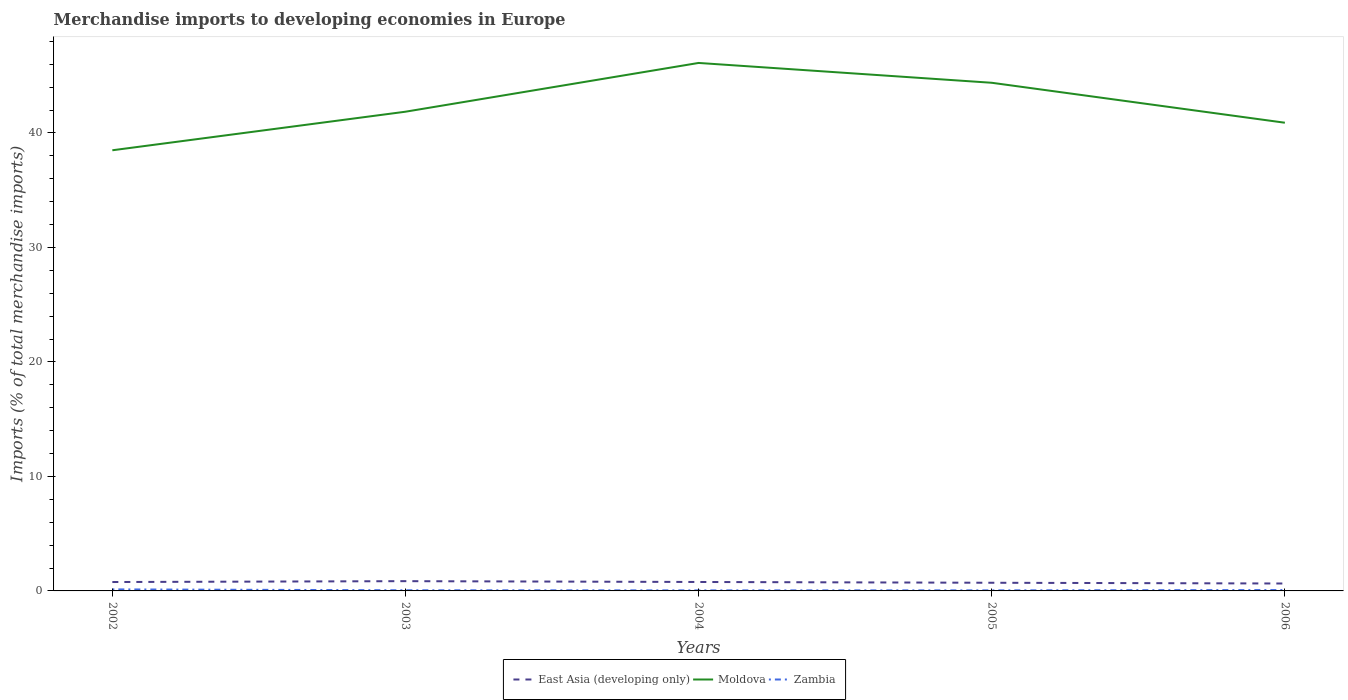Is the number of lines equal to the number of legend labels?
Provide a succinct answer. Yes. Across all years, what is the maximum percentage total merchandise imports in Zambia?
Give a very brief answer. 0.05. What is the total percentage total merchandise imports in East Asia (developing only) in the graph?
Make the answer very short. 0.07. What is the difference between the highest and the second highest percentage total merchandise imports in Moldova?
Offer a terse response. 7.63. Does the graph contain grids?
Ensure brevity in your answer.  No. Where does the legend appear in the graph?
Provide a short and direct response. Bottom center. How many legend labels are there?
Offer a very short reply. 3. What is the title of the graph?
Your answer should be very brief. Merchandise imports to developing economies in Europe. What is the label or title of the Y-axis?
Keep it short and to the point. Imports (% of total merchandise imports). What is the Imports (% of total merchandise imports) in East Asia (developing only) in 2002?
Your answer should be very brief. 0.78. What is the Imports (% of total merchandise imports) in Moldova in 2002?
Keep it short and to the point. 38.49. What is the Imports (% of total merchandise imports) in Zambia in 2002?
Provide a short and direct response. 0.13. What is the Imports (% of total merchandise imports) in East Asia (developing only) in 2003?
Offer a very short reply. 0.85. What is the Imports (% of total merchandise imports) in Moldova in 2003?
Make the answer very short. 41.86. What is the Imports (% of total merchandise imports) in Zambia in 2003?
Make the answer very short. 0.06. What is the Imports (% of total merchandise imports) in East Asia (developing only) in 2004?
Make the answer very short. 0.78. What is the Imports (% of total merchandise imports) of Moldova in 2004?
Your answer should be compact. 46.12. What is the Imports (% of total merchandise imports) of Zambia in 2004?
Make the answer very short. 0.05. What is the Imports (% of total merchandise imports) of East Asia (developing only) in 2005?
Give a very brief answer. 0.71. What is the Imports (% of total merchandise imports) of Moldova in 2005?
Ensure brevity in your answer.  44.39. What is the Imports (% of total merchandise imports) of Zambia in 2005?
Your answer should be very brief. 0.05. What is the Imports (% of total merchandise imports) of East Asia (developing only) in 2006?
Your response must be concise. 0.65. What is the Imports (% of total merchandise imports) of Moldova in 2006?
Provide a short and direct response. 40.9. What is the Imports (% of total merchandise imports) of Zambia in 2006?
Give a very brief answer. 0.08. Across all years, what is the maximum Imports (% of total merchandise imports) in East Asia (developing only)?
Offer a terse response. 0.85. Across all years, what is the maximum Imports (% of total merchandise imports) in Moldova?
Provide a succinct answer. 46.12. Across all years, what is the maximum Imports (% of total merchandise imports) in Zambia?
Your response must be concise. 0.13. Across all years, what is the minimum Imports (% of total merchandise imports) in East Asia (developing only)?
Ensure brevity in your answer.  0.65. Across all years, what is the minimum Imports (% of total merchandise imports) in Moldova?
Ensure brevity in your answer.  38.49. Across all years, what is the minimum Imports (% of total merchandise imports) of Zambia?
Make the answer very short. 0.05. What is the total Imports (% of total merchandise imports) of East Asia (developing only) in the graph?
Offer a very short reply. 3.77. What is the total Imports (% of total merchandise imports) in Moldova in the graph?
Your answer should be compact. 211.75. What is the total Imports (% of total merchandise imports) of Zambia in the graph?
Your response must be concise. 0.36. What is the difference between the Imports (% of total merchandise imports) in East Asia (developing only) in 2002 and that in 2003?
Provide a succinct answer. -0.08. What is the difference between the Imports (% of total merchandise imports) of Moldova in 2002 and that in 2003?
Provide a short and direct response. -3.37. What is the difference between the Imports (% of total merchandise imports) in Zambia in 2002 and that in 2003?
Provide a succinct answer. 0.08. What is the difference between the Imports (% of total merchandise imports) of East Asia (developing only) in 2002 and that in 2004?
Your response must be concise. -0. What is the difference between the Imports (% of total merchandise imports) in Moldova in 2002 and that in 2004?
Offer a terse response. -7.63. What is the difference between the Imports (% of total merchandise imports) in Zambia in 2002 and that in 2004?
Provide a succinct answer. 0.09. What is the difference between the Imports (% of total merchandise imports) in East Asia (developing only) in 2002 and that in 2005?
Keep it short and to the point. 0.06. What is the difference between the Imports (% of total merchandise imports) in Moldova in 2002 and that in 2005?
Keep it short and to the point. -5.9. What is the difference between the Imports (% of total merchandise imports) of Zambia in 2002 and that in 2005?
Keep it short and to the point. 0.09. What is the difference between the Imports (% of total merchandise imports) in East Asia (developing only) in 2002 and that in 2006?
Provide a short and direct response. 0.13. What is the difference between the Imports (% of total merchandise imports) of Moldova in 2002 and that in 2006?
Give a very brief answer. -2.41. What is the difference between the Imports (% of total merchandise imports) in Zambia in 2002 and that in 2006?
Offer a terse response. 0.06. What is the difference between the Imports (% of total merchandise imports) in East Asia (developing only) in 2003 and that in 2004?
Make the answer very short. 0.07. What is the difference between the Imports (% of total merchandise imports) in Moldova in 2003 and that in 2004?
Offer a very short reply. -4.26. What is the difference between the Imports (% of total merchandise imports) in Zambia in 2003 and that in 2004?
Make the answer very short. 0.01. What is the difference between the Imports (% of total merchandise imports) in East Asia (developing only) in 2003 and that in 2005?
Offer a very short reply. 0.14. What is the difference between the Imports (% of total merchandise imports) in Moldova in 2003 and that in 2005?
Offer a terse response. -2.53. What is the difference between the Imports (% of total merchandise imports) in Zambia in 2003 and that in 2005?
Provide a short and direct response. 0.01. What is the difference between the Imports (% of total merchandise imports) of East Asia (developing only) in 2003 and that in 2006?
Ensure brevity in your answer.  0.2. What is the difference between the Imports (% of total merchandise imports) in Moldova in 2003 and that in 2006?
Provide a short and direct response. 0.96. What is the difference between the Imports (% of total merchandise imports) of Zambia in 2003 and that in 2006?
Provide a succinct answer. -0.02. What is the difference between the Imports (% of total merchandise imports) of East Asia (developing only) in 2004 and that in 2005?
Your response must be concise. 0.07. What is the difference between the Imports (% of total merchandise imports) of Moldova in 2004 and that in 2005?
Offer a very short reply. 1.73. What is the difference between the Imports (% of total merchandise imports) of Zambia in 2004 and that in 2005?
Offer a very short reply. -0. What is the difference between the Imports (% of total merchandise imports) in East Asia (developing only) in 2004 and that in 2006?
Offer a terse response. 0.13. What is the difference between the Imports (% of total merchandise imports) in Moldova in 2004 and that in 2006?
Offer a terse response. 5.22. What is the difference between the Imports (% of total merchandise imports) of Zambia in 2004 and that in 2006?
Give a very brief answer. -0.03. What is the difference between the Imports (% of total merchandise imports) in East Asia (developing only) in 2005 and that in 2006?
Offer a terse response. 0.07. What is the difference between the Imports (% of total merchandise imports) of Moldova in 2005 and that in 2006?
Your response must be concise. 3.49. What is the difference between the Imports (% of total merchandise imports) of Zambia in 2005 and that in 2006?
Give a very brief answer. -0.03. What is the difference between the Imports (% of total merchandise imports) of East Asia (developing only) in 2002 and the Imports (% of total merchandise imports) of Moldova in 2003?
Provide a short and direct response. -41.08. What is the difference between the Imports (% of total merchandise imports) in East Asia (developing only) in 2002 and the Imports (% of total merchandise imports) in Zambia in 2003?
Your answer should be very brief. 0.72. What is the difference between the Imports (% of total merchandise imports) of Moldova in 2002 and the Imports (% of total merchandise imports) of Zambia in 2003?
Keep it short and to the point. 38.43. What is the difference between the Imports (% of total merchandise imports) of East Asia (developing only) in 2002 and the Imports (% of total merchandise imports) of Moldova in 2004?
Your answer should be compact. -45.34. What is the difference between the Imports (% of total merchandise imports) in East Asia (developing only) in 2002 and the Imports (% of total merchandise imports) in Zambia in 2004?
Offer a terse response. 0.73. What is the difference between the Imports (% of total merchandise imports) in Moldova in 2002 and the Imports (% of total merchandise imports) in Zambia in 2004?
Offer a terse response. 38.44. What is the difference between the Imports (% of total merchandise imports) of East Asia (developing only) in 2002 and the Imports (% of total merchandise imports) of Moldova in 2005?
Provide a short and direct response. -43.61. What is the difference between the Imports (% of total merchandise imports) in East Asia (developing only) in 2002 and the Imports (% of total merchandise imports) in Zambia in 2005?
Make the answer very short. 0.73. What is the difference between the Imports (% of total merchandise imports) of Moldova in 2002 and the Imports (% of total merchandise imports) of Zambia in 2005?
Offer a very short reply. 38.44. What is the difference between the Imports (% of total merchandise imports) in East Asia (developing only) in 2002 and the Imports (% of total merchandise imports) in Moldova in 2006?
Your answer should be very brief. -40.12. What is the difference between the Imports (% of total merchandise imports) in East Asia (developing only) in 2002 and the Imports (% of total merchandise imports) in Zambia in 2006?
Give a very brief answer. 0.7. What is the difference between the Imports (% of total merchandise imports) in Moldova in 2002 and the Imports (% of total merchandise imports) in Zambia in 2006?
Keep it short and to the point. 38.41. What is the difference between the Imports (% of total merchandise imports) of East Asia (developing only) in 2003 and the Imports (% of total merchandise imports) of Moldova in 2004?
Provide a short and direct response. -45.27. What is the difference between the Imports (% of total merchandise imports) of East Asia (developing only) in 2003 and the Imports (% of total merchandise imports) of Zambia in 2004?
Keep it short and to the point. 0.81. What is the difference between the Imports (% of total merchandise imports) of Moldova in 2003 and the Imports (% of total merchandise imports) of Zambia in 2004?
Make the answer very short. 41.81. What is the difference between the Imports (% of total merchandise imports) of East Asia (developing only) in 2003 and the Imports (% of total merchandise imports) of Moldova in 2005?
Your response must be concise. -43.53. What is the difference between the Imports (% of total merchandise imports) in East Asia (developing only) in 2003 and the Imports (% of total merchandise imports) in Zambia in 2005?
Provide a succinct answer. 0.8. What is the difference between the Imports (% of total merchandise imports) in Moldova in 2003 and the Imports (% of total merchandise imports) in Zambia in 2005?
Give a very brief answer. 41.81. What is the difference between the Imports (% of total merchandise imports) of East Asia (developing only) in 2003 and the Imports (% of total merchandise imports) of Moldova in 2006?
Your response must be concise. -40.04. What is the difference between the Imports (% of total merchandise imports) of East Asia (developing only) in 2003 and the Imports (% of total merchandise imports) of Zambia in 2006?
Ensure brevity in your answer.  0.78. What is the difference between the Imports (% of total merchandise imports) of Moldova in 2003 and the Imports (% of total merchandise imports) of Zambia in 2006?
Make the answer very short. 41.78. What is the difference between the Imports (% of total merchandise imports) of East Asia (developing only) in 2004 and the Imports (% of total merchandise imports) of Moldova in 2005?
Your answer should be compact. -43.6. What is the difference between the Imports (% of total merchandise imports) in East Asia (developing only) in 2004 and the Imports (% of total merchandise imports) in Zambia in 2005?
Offer a terse response. 0.73. What is the difference between the Imports (% of total merchandise imports) of Moldova in 2004 and the Imports (% of total merchandise imports) of Zambia in 2005?
Your answer should be very brief. 46.07. What is the difference between the Imports (% of total merchandise imports) in East Asia (developing only) in 2004 and the Imports (% of total merchandise imports) in Moldova in 2006?
Make the answer very short. -40.12. What is the difference between the Imports (% of total merchandise imports) of East Asia (developing only) in 2004 and the Imports (% of total merchandise imports) of Zambia in 2006?
Your answer should be very brief. 0.7. What is the difference between the Imports (% of total merchandise imports) in Moldova in 2004 and the Imports (% of total merchandise imports) in Zambia in 2006?
Make the answer very short. 46.04. What is the difference between the Imports (% of total merchandise imports) of East Asia (developing only) in 2005 and the Imports (% of total merchandise imports) of Moldova in 2006?
Give a very brief answer. -40.18. What is the difference between the Imports (% of total merchandise imports) of East Asia (developing only) in 2005 and the Imports (% of total merchandise imports) of Zambia in 2006?
Make the answer very short. 0.64. What is the difference between the Imports (% of total merchandise imports) in Moldova in 2005 and the Imports (% of total merchandise imports) in Zambia in 2006?
Provide a short and direct response. 44.31. What is the average Imports (% of total merchandise imports) in East Asia (developing only) per year?
Provide a short and direct response. 0.75. What is the average Imports (% of total merchandise imports) of Moldova per year?
Offer a terse response. 42.35. What is the average Imports (% of total merchandise imports) in Zambia per year?
Offer a very short reply. 0.07. In the year 2002, what is the difference between the Imports (% of total merchandise imports) in East Asia (developing only) and Imports (% of total merchandise imports) in Moldova?
Provide a succinct answer. -37.71. In the year 2002, what is the difference between the Imports (% of total merchandise imports) in East Asia (developing only) and Imports (% of total merchandise imports) in Zambia?
Your answer should be compact. 0.64. In the year 2002, what is the difference between the Imports (% of total merchandise imports) of Moldova and Imports (% of total merchandise imports) of Zambia?
Your answer should be very brief. 38.36. In the year 2003, what is the difference between the Imports (% of total merchandise imports) of East Asia (developing only) and Imports (% of total merchandise imports) of Moldova?
Your response must be concise. -41.01. In the year 2003, what is the difference between the Imports (% of total merchandise imports) in East Asia (developing only) and Imports (% of total merchandise imports) in Zambia?
Ensure brevity in your answer.  0.8. In the year 2003, what is the difference between the Imports (% of total merchandise imports) of Moldova and Imports (% of total merchandise imports) of Zambia?
Offer a terse response. 41.8. In the year 2004, what is the difference between the Imports (% of total merchandise imports) in East Asia (developing only) and Imports (% of total merchandise imports) in Moldova?
Give a very brief answer. -45.34. In the year 2004, what is the difference between the Imports (% of total merchandise imports) of East Asia (developing only) and Imports (% of total merchandise imports) of Zambia?
Your response must be concise. 0.73. In the year 2004, what is the difference between the Imports (% of total merchandise imports) of Moldova and Imports (% of total merchandise imports) of Zambia?
Keep it short and to the point. 46.07. In the year 2005, what is the difference between the Imports (% of total merchandise imports) of East Asia (developing only) and Imports (% of total merchandise imports) of Moldova?
Make the answer very short. -43.67. In the year 2005, what is the difference between the Imports (% of total merchandise imports) in East Asia (developing only) and Imports (% of total merchandise imports) in Zambia?
Provide a succinct answer. 0.67. In the year 2005, what is the difference between the Imports (% of total merchandise imports) in Moldova and Imports (% of total merchandise imports) in Zambia?
Your response must be concise. 44.34. In the year 2006, what is the difference between the Imports (% of total merchandise imports) in East Asia (developing only) and Imports (% of total merchandise imports) in Moldova?
Keep it short and to the point. -40.25. In the year 2006, what is the difference between the Imports (% of total merchandise imports) in East Asia (developing only) and Imports (% of total merchandise imports) in Zambia?
Ensure brevity in your answer.  0.57. In the year 2006, what is the difference between the Imports (% of total merchandise imports) in Moldova and Imports (% of total merchandise imports) in Zambia?
Your response must be concise. 40.82. What is the ratio of the Imports (% of total merchandise imports) in East Asia (developing only) in 2002 to that in 2003?
Your answer should be very brief. 0.91. What is the ratio of the Imports (% of total merchandise imports) of Moldova in 2002 to that in 2003?
Your answer should be compact. 0.92. What is the ratio of the Imports (% of total merchandise imports) of Zambia in 2002 to that in 2003?
Your answer should be very brief. 2.39. What is the ratio of the Imports (% of total merchandise imports) of Moldova in 2002 to that in 2004?
Offer a very short reply. 0.83. What is the ratio of the Imports (% of total merchandise imports) of Zambia in 2002 to that in 2004?
Offer a terse response. 2.88. What is the ratio of the Imports (% of total merchandise imports) in East Asia (developing only) in 2002 to that in 2005?
Give a very brief answer. 1.09. What is the ratio of the Imports (% of total merchandise imports) in Moldova in 2002 to that in 2005?
Your response must be concise. 0.87. What is the ratio of the Imports (% of total merchandise imports) in Zambia in 2002 to that in 2005?
Offer a very short reply. 2.8. What is the ratio of the Imports (% of total merchandise imports) in East Asia (developing only) in 2002 to that in 2006?
Your response must be concise. 1.2. What is the ratio of the Imports (% of total merchandise imports) of Moldova in 2002 to that in 2006?
Keep it short and to the point. 0.94. What is the ratio of the Imports (% of total merchandise imports) of Zambia in 2002 to that in 2006?
Offer a very short reply. 1.75. What is the ratio of the Imports (% of total merchandise imports) of East Asia (developing only) in 2003 to that in 2004?
Keep it short and to the point. 1.09. What is the ratio of the Imports (% of total merchandise imports) in Moldova in 2003 to that in 2004?
Provide a succinct answer. 0.91. What is the ratio of the Imports (% of total merchandise imports) of Zambia in 2003 to that in 2004?
Offer a very short reply. 1.2. What is the ratio of the Imports (% of total merchandise imports) of East Asia (developing only) in 2003 to that in 2005?
Give a very brief answer. 1.2. What is the ratio of the Imports (% of total merchandise imports) of Moldova in 2003 to that in 2005?
Keep it short and to the point. 0.94. What is the ratio of the Imports (% of total merchandise imports) of Zambia in 2003 to that in 2005?
Offer a terse response. 1.17. What is the ratio of the Imports (% of total merchandise imports) in East Asia (developing only) in 2003 to that in 2006?
Your response must be concise. 1.32. What is the ratio of the Imports (% of total merchandise imports) of Moldova in 2003 to that in 2006?
Your answer should be compact. 1.02. What is the ratio of the Imports (% of total merchandise imports) in Zambia in 2003 to that in 2006?
Your answer should be compact. 0.73. What is the ratio of the Imports (% of total merchandise imports) in East Asia (developing only) in 2004 to that in 2005?
Provide a succinct answer. 1.1. What is the ratio of the Imports (% of total merchandise imports) in Moldova in 2004 to that in 2005?
Provide a succinct answer. 1.04. What is the ratio of the Imports (% of total merchandise imports) of Zambia in 2004 to that in 2005?
Provide a succinct answer. 0.97. What is the ratio of the Imports (% of total merchandise imports) of East Asia (developing only) in 2004 to that in 2006?
Provide a succinct answer. 1.21. What is the ratio of the Imports (% of total merchandise imports) of Moldova in 2004 to that in 2006?
Offer a terse response. 1.13. What is the ratio of the Imports (% of total merchandise imports) in Zambia in 2004 to that in 2006?
Your response must be concise. 0.61. What is the ratio of the Imports (% of total merchandise imports) of East Asia (developing only) in 2005 to that in 2006?
Ensure brevity in your answer.  1.1. What is the ratio of the Imports (% of total merchandise imports) in Moldova in 2005 to that in 2006?
Offer a terse response. 1.09. What is the ratio of the Imports (% of total merchandise imports) in Zambia in 2005 to that in 2006?
Your answer should be very brief. 0.62. What is the difference between the highest and the second highest Imports (% of total merchandise imports) of East Asia (developing only)?
Your answer should be very brief. 0.07. What is the difference between the highest and the second highest Imports (% of total merchandise imports) of Moldova?
Ensure brevity in your answer.  1.73. What is the difference between the highest and the second highest Imports (% of total merchandise imports) of Zambia?
Offer a terse response. 0.06. What is the difference between the highest and the lowest Imports (% of total merchandise imports) in East Asia (developing only)?
Offer a terse response. 0.2. What is the difference between the highest and the lowest Imports (% of total merchandise imports) of Moldova?
Offer a terse response. 7.63. What is the difference between the highest and the lowest Imports (% of total merchandise imports) in Zambia?
Your answer should be very brief. 0.09. 